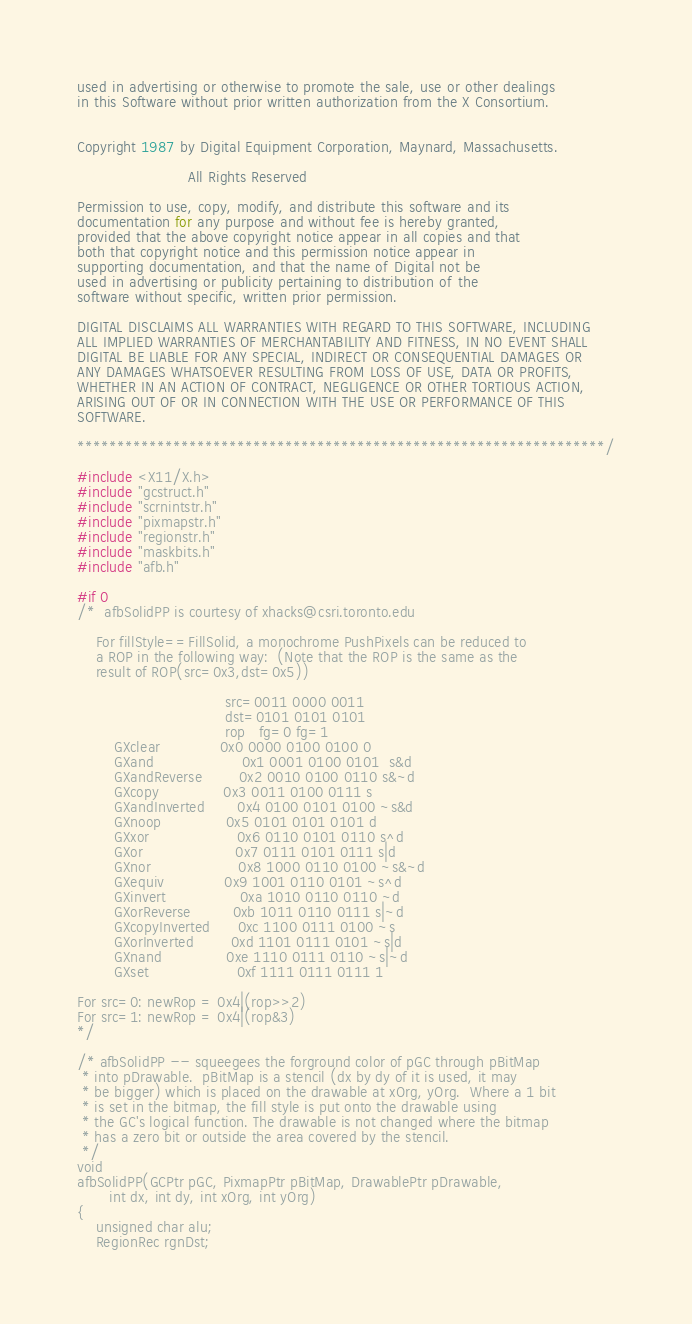Convert code to text. <code><loc_0><loc_0><loc_500><loc_500><_C_>used in advertising or otherwise to promote the sale, use or other dealings
in this Software without prior written authorization from the X Consortium.


Copyright 1987 by Digital Equipment Corporation, Maynard, Massachusetts.

                        All Rights Reserved

Permission to use, copy, modify, and distribute this software and its
documentation for any purpose and without fee is hereby granted,
provided that the above copyright notice appear in all copies and that
both that copyright notice and this permission notice appear in
supporting documentation, and that the name of Digital not be
used in advertising or publicity pertaining to distribution of the
software without specific, written prior permission.

DIGITAL DISCLAIMS ALL WARRANTIES WITH REGARD TO THIS SOFTWARE, INCLUDING
ALL IMPLIED WARRANTIES OF MERCHANTABILITY AND FITNESS, IN NO EVENT SHALL
DIGITAL BE LIABLE FOR ANY SPECIAL, INDIRECT OR CONSEQUENTIAL DAMAGES OR
ANY DAMAGES WHATSOEVER RESULTING FROM LOSS OF USE, DATA OR PROFITS,
WHETHER IN AN ACTION OF CONTRACT, NEGLIGENCE OR OTHER TORTIOUS ACTION,
ARISING OUT OF OR IN CONNECTION WITH THE USE OR PERFORMANCE OF THIS
SOFTWARE.

******************************************************************/

#include <X11/X.h>
#include "gcstruct.h"
#include "scrnintstr.h"
#include "pixmapstr.h"
#include "regionstr.h"
#include "maskbits.h"
#include "afb.h"

#if 0
/*  afbSolidPP is courtesy of xhacks@csri.toronto.edu

	For fillStyle==FillSolid, a monochrome PushPixels can be reduced to
	a ROP in the following way:  (Note that the ROP is the same as the
	result of ROP(src=0x3,dst=0x5))

								src=0011 0000 0011
								dst=0101 0101 0101
								rop	  fg=0 fg=1
		GXclear				0x0 0000 0100 0100 0
		GXand					0x1 0001 0100 0101  s&d
		GXandReverse		0x2 0010 0100 0110 s&~d
		GXcopy				0x3 0011 0100 0111 s
		GXandInverted		0x4 0100 0101 0100 ~s&d
		GXnoop				0x5 0101 0101 0101 d
		GXxor					0x6 0110 0101 0110 s^d
		GXor					0x7 0111 0101 0111 s|d
		GXnor					0x8 1000 0110 0100 ~s&~d
		GXequiv				0x9 1001 0110 0101 ~s^d
		GXinvert				0xa 1010 0110 0110 ~d
		GXorReverse			0xb 1011 0110 0111 s|~d
		GXcopyInverted		0xc 1100 0111 0100 ~s
		GXorInverted		0xd 1101 0111 0101 ~s|d
		GXnand				0xe 1110 0111 0110 ~s|~d
		GXset					0xf 1111 0111 0111 1

For src=0: newRop = 0x4|(rop>>2)
For src=1: newRop = 0x4|(rop&3)
*/

/* afbSolidPP -- squeegees the forground color of pGC through pBitMap
 * into pDrawable.  pBitMap is a stencil (dx by dy of it is used, it may
 * be bigger) which is placed on the drawable at xOrg, yOrg.  Where a 1 bit
 * is set in the bitmap, the fill style is put onto the drawable using
 * the GC's logical function. The drawable is not changed where the bitmap
 * has a zero bit or outside the area covered by the stencil.
 */
void
afbSolidPP(GCPtr pGC, PixmapPtr pBitMap, DrawablePtr pDrawable,
	   int dx, int dy, int xOrg, int yOrg)
{
	unsigned char alu;
	RegionRec rgnDst;</code> 